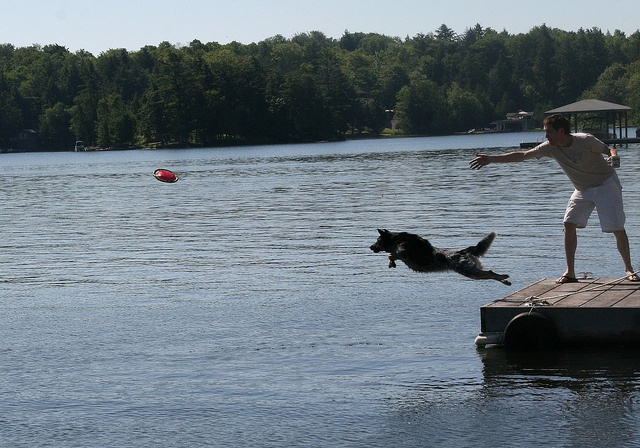Describe the objects in this image and their specific colors. I can see people in lightgray, black, gray, and darkgray tones, dog in lightgray, black, gray, and darkgray tones, and frisbee in lightgray, black, maroon, gray, and brown tones in this image. 